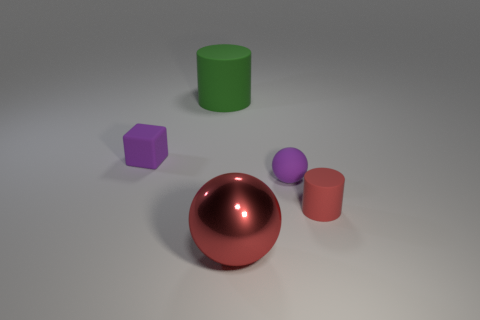What color is the tiny matte sphere?
Provide a short and direct response. Purple. Is the big metal ball the same color as the small rubber block?
Provide a succinct answer. No. Are the red sphere that is to the right of the tiny purple rubber cube and the purple object that is in front of the small purple block made of the same material?
Make the answer very short. No. There is a tiny thing that is the same shape as the large red shiny object; what material is it?
Keep it short and to the point. Rubber. Is the material of the purple ball the same as the small purple cube?
Ensure brevity in your answer.  Yes. There is a tiny matte thing that is to the left of the cylinder that is left of the small cylinder; what is its color?
Make the answer very short. Purple. There is a cylinder that is the same material as the tiny red object; what size is it?
Provide a succinct answer. Large. What number of tiny red things have the same shape as the big rubber thing?
Ensure brevity in your answer.  1. How many objects are either big red objects on the left side of the tiny red cylinder or rubber cylinders that are left of the small cylinder?
Offer a terse response. 2. There is a metal ball that is in front of the matte sphere; how many large cylinders are on the left side of it?
Provide a succinct answer. 1. 